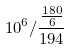<formula> <loc_0><loc_0><loc_500><loc_500>1 0 ^ { 6 } / \frac { \frac { 1 8 0 } { 6 } } { 1 9 4 }</formula> 